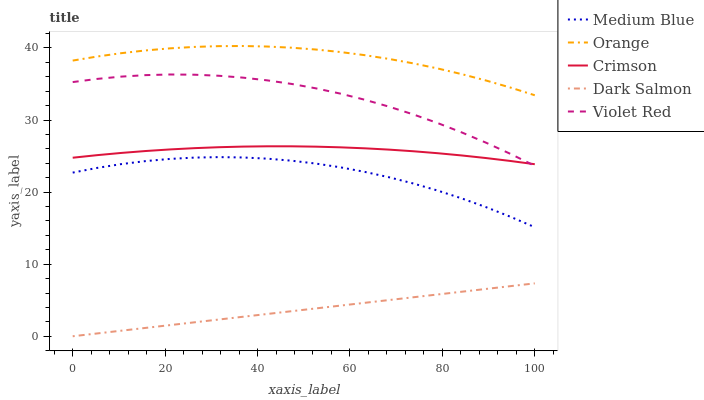Does Dark Salmon have the minimum area under the curve?
Answer yes or no. Yes. Does Orange have the maximum area under the curve?
Answer yes or no. Yes. Does Crimson have the minimum area under the curve?
Answer yes or no. No. Does Crimson have the maximum area under the curve?
Answer yes or no. No. Is Dark Salmon the smoothest?
Answer yes or no. Yes. Is Violet Red the roughest?
Answer yes or no. Yes. Is Crimson the smoothest?
Answer yes or no. No. Is Crimson the roughest?
Answer yes or no. No. Does Dark Salmon have the lowest value?
Answer yes or no. Yes. Does Crimson have the lowest value?
Answer yes or no. No. Does Orange have the highest value?
Answer yes or no. Yes. Does Crimson have the highest value?
Answer yes or no. No. Is Dark Salmon less than Crimson?
Answer yes or no. Yes. Is Violet Red greater than Medium Blue?
Answer yes or no. Yes. Does Violet Red intersect Crimson?
Answer yes or no. Yes. Is Violet Red less than Crimson?
Answer yes or no. No. Is Violet Red greater than Crimson?
Answer yes or no. No. Does Dark Salmon intersect Crimson?
Answer yes or no. No. 